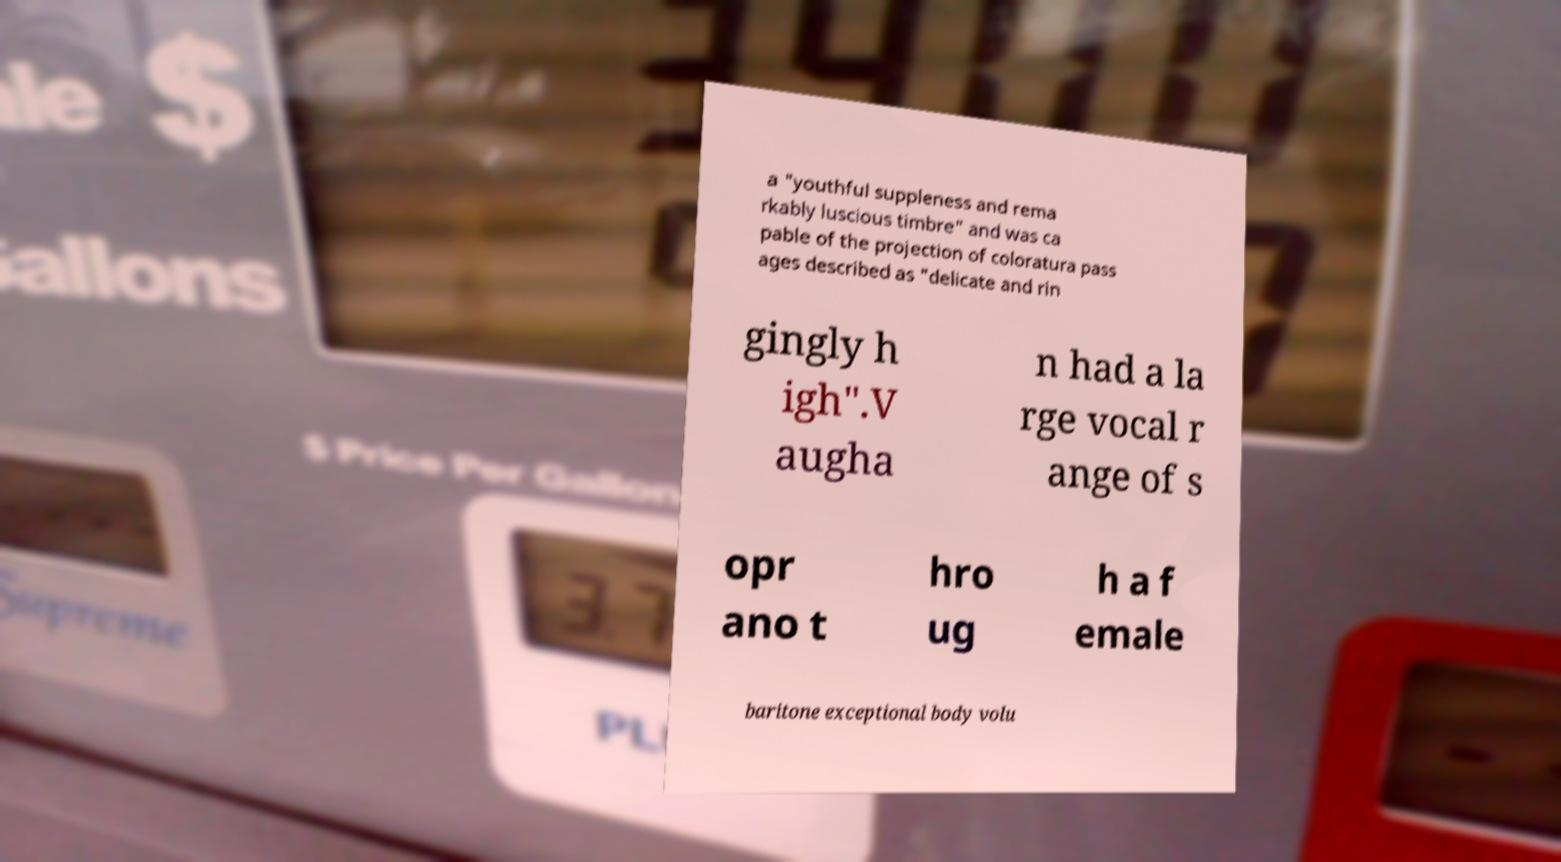I need the written content from this picture converted into text. Can you do that? a "youthful suppleness and rema rkably luscious timbre" and was ca pable of the projection of coloratura pass ages described as "delicate and rin gingly h igh".V augha n had a la rge vocal r ange of s opr ano t hro ug h a f emale baritone exceptional body volu 